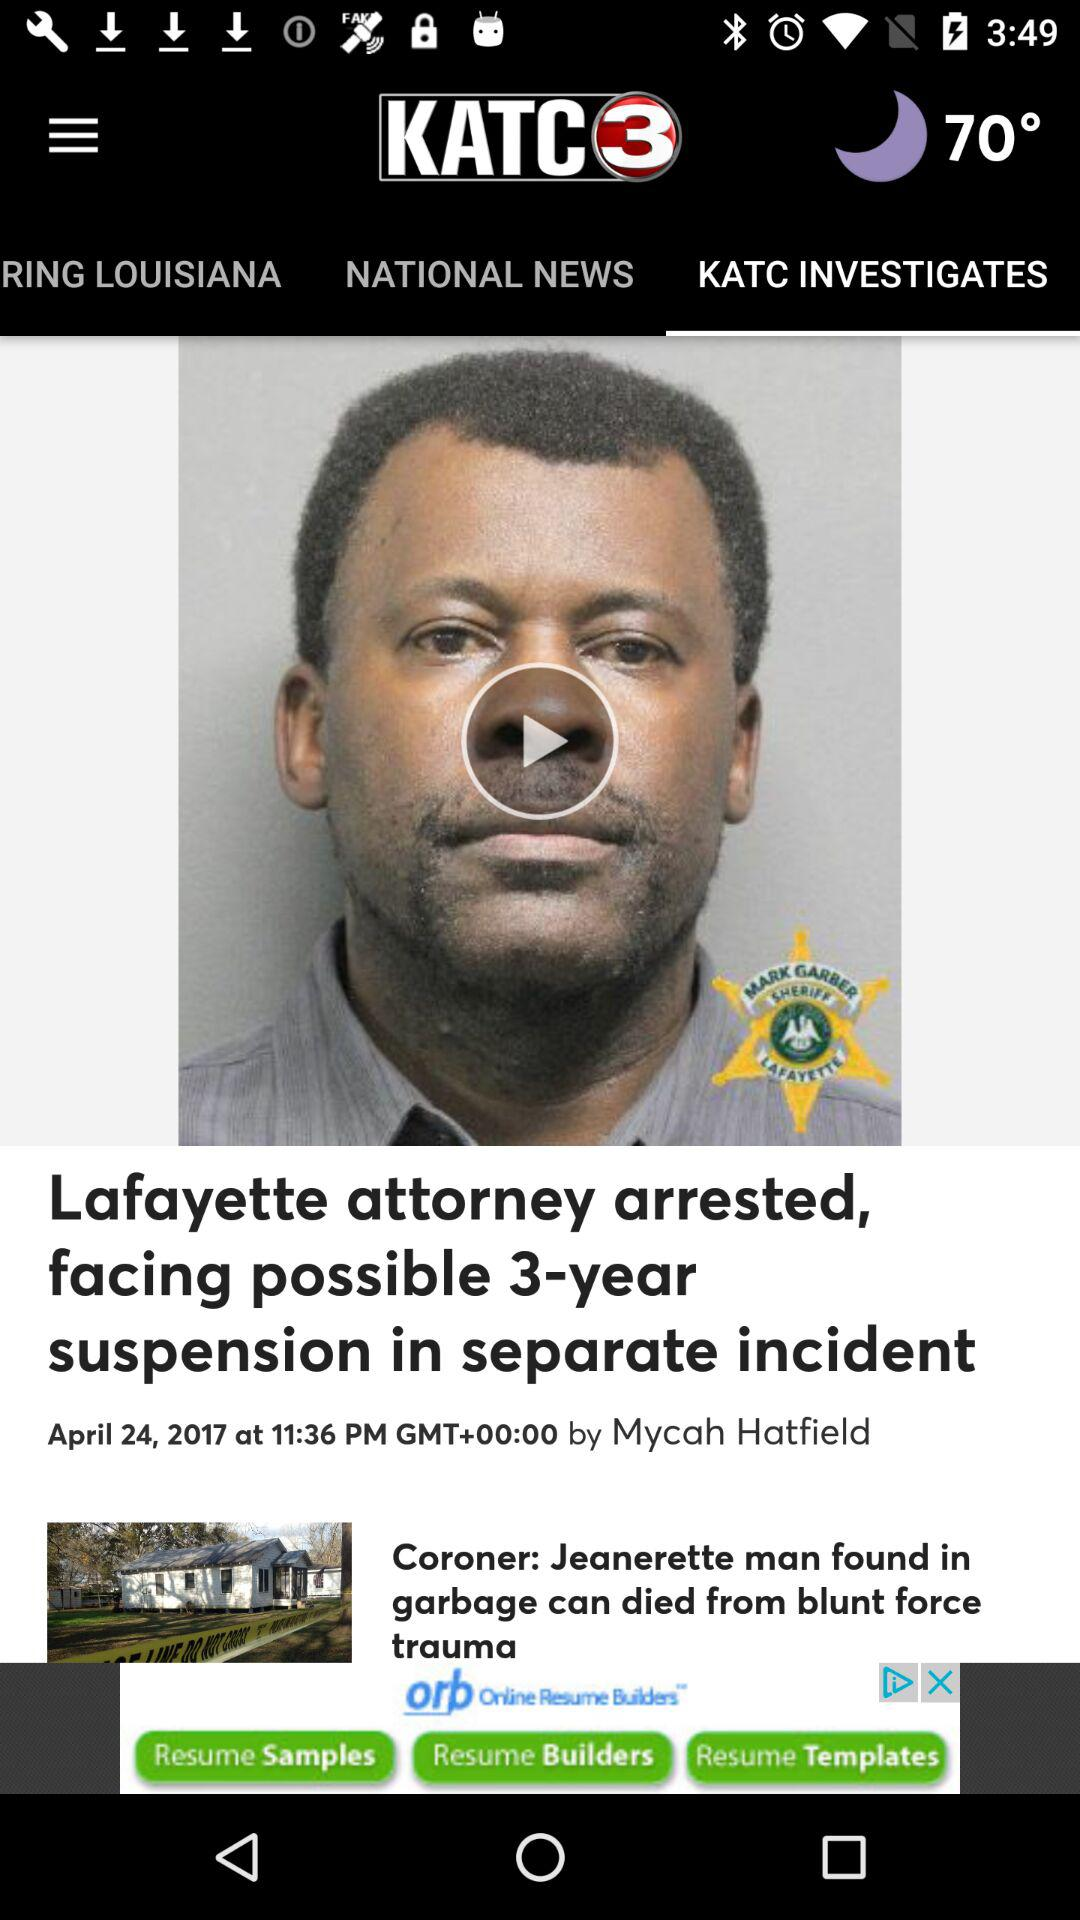What is the investigation news posting time? The investigation news posting time is 11:36 PM. 